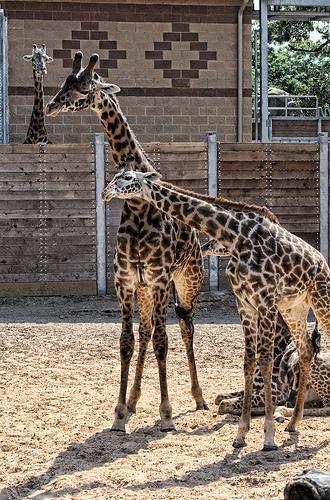How many giraffes are laying down?
Give a very brief answer. 1. How many giraffes are in the box?
Give a very brief answer. 2. How many giraffes are pictured?
Give a very brief answer. 3. 